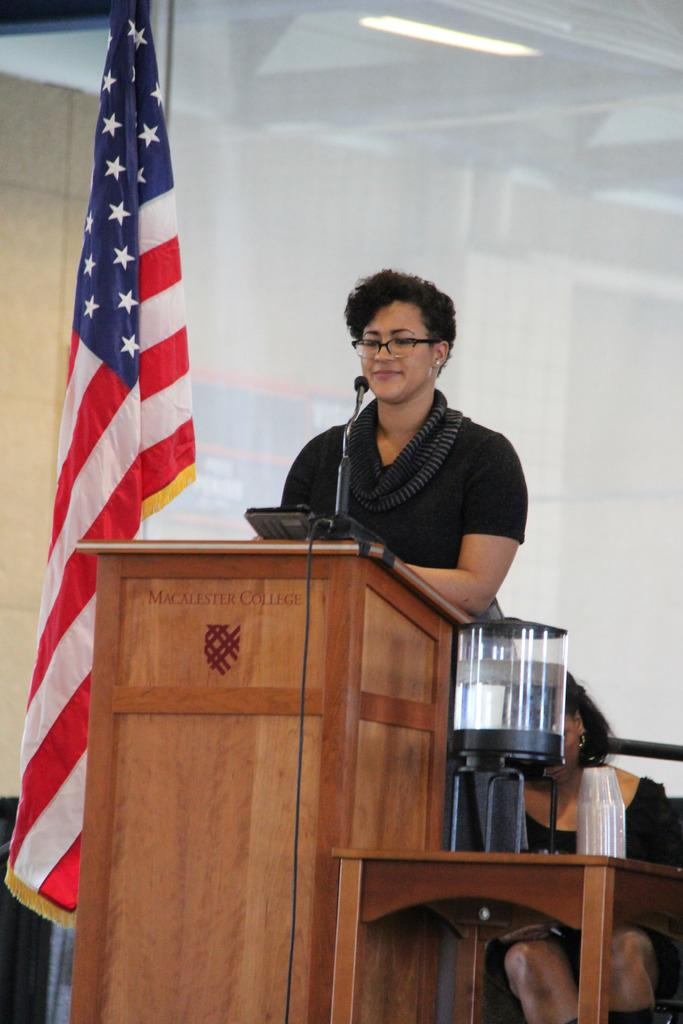<image>
Provide a brief description of the given image. a woman standing behind a podium that says 'macalester college' 